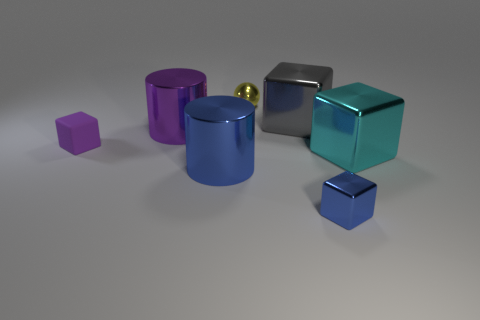Are there any other things that are made of the same material as the large purple cylinder?
Keep it short and to the point. Yes. There is a purple rubber object that is the same shape as the large gray metal object; what size is it?
Offer a very short reply. Small. Is the number of tiny objects that are in front of the tiny purple cube less than the number of big blocks that are behind the shiny sphere?
Give a very brief answer. No. What shape is the shiny thing that is in front of the purple metal object and to the left of the sphere?
Offer a terse response. Cylinder. There is a yellow ball that is the same material as the blue cube; what is its size?
Your answer should be very brief. Small. Does the small rubber object have the same color as the small metallic thing that is right of the yellow metal ball?
Keep it short and to the point. No. There is a small thing that is in front of the big purple cylinder and right of the tiny rubber cube; what is its material?
Your answer should be compact. Metal. There is a object that is the same color as the tiny metal block; what size is it?
Offer a terse response. Large. There is a small metal object that is in front of the matte thing; is its shape the same as the small metal thing that is behind the cyan metal object?
Your answer should be compact. No. Are any yellow metallic cylinders visible?
Your answer should be compact. No. 